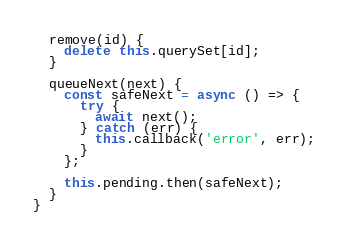<code> <loc_0><loc_0><loc_500><loc_500><_JavaScript_>  remove(id) {
    delete this.querySet[id];
  }

  queueNext(next) {
    const safeNext = async () => {
      try {
        await next();
      } catch (err) {
        this.callback('error', err);
      }
    };

    this.pending.then(safeNext);
  }
}
</code> 